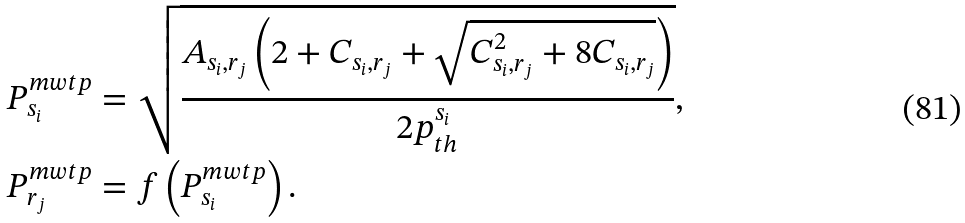Convert formula to latex. <formula><loc_0><loc_0><loc_500><loc_500>P _ { s _ { i } } ^ { m w t p } & = \sqrt { \frac { A _ { s _ { i } , r _ { j } } \left ( 2 + C _ { s _ { i } , r _ { j } } + \sqrt { C _ { s _ { i } , r _ { j } } ^ { 2 } + 8 C _ { s _ { i } , r _ { j } } } \right ) } { 2 p _ { t h } ^ { s _ { i } } } } , \\ P _ { r _ { j } } ^ { m w t p } & = f \left ( P _ { s _ { i } } ^ { m w t p } \right ) .</formula> 